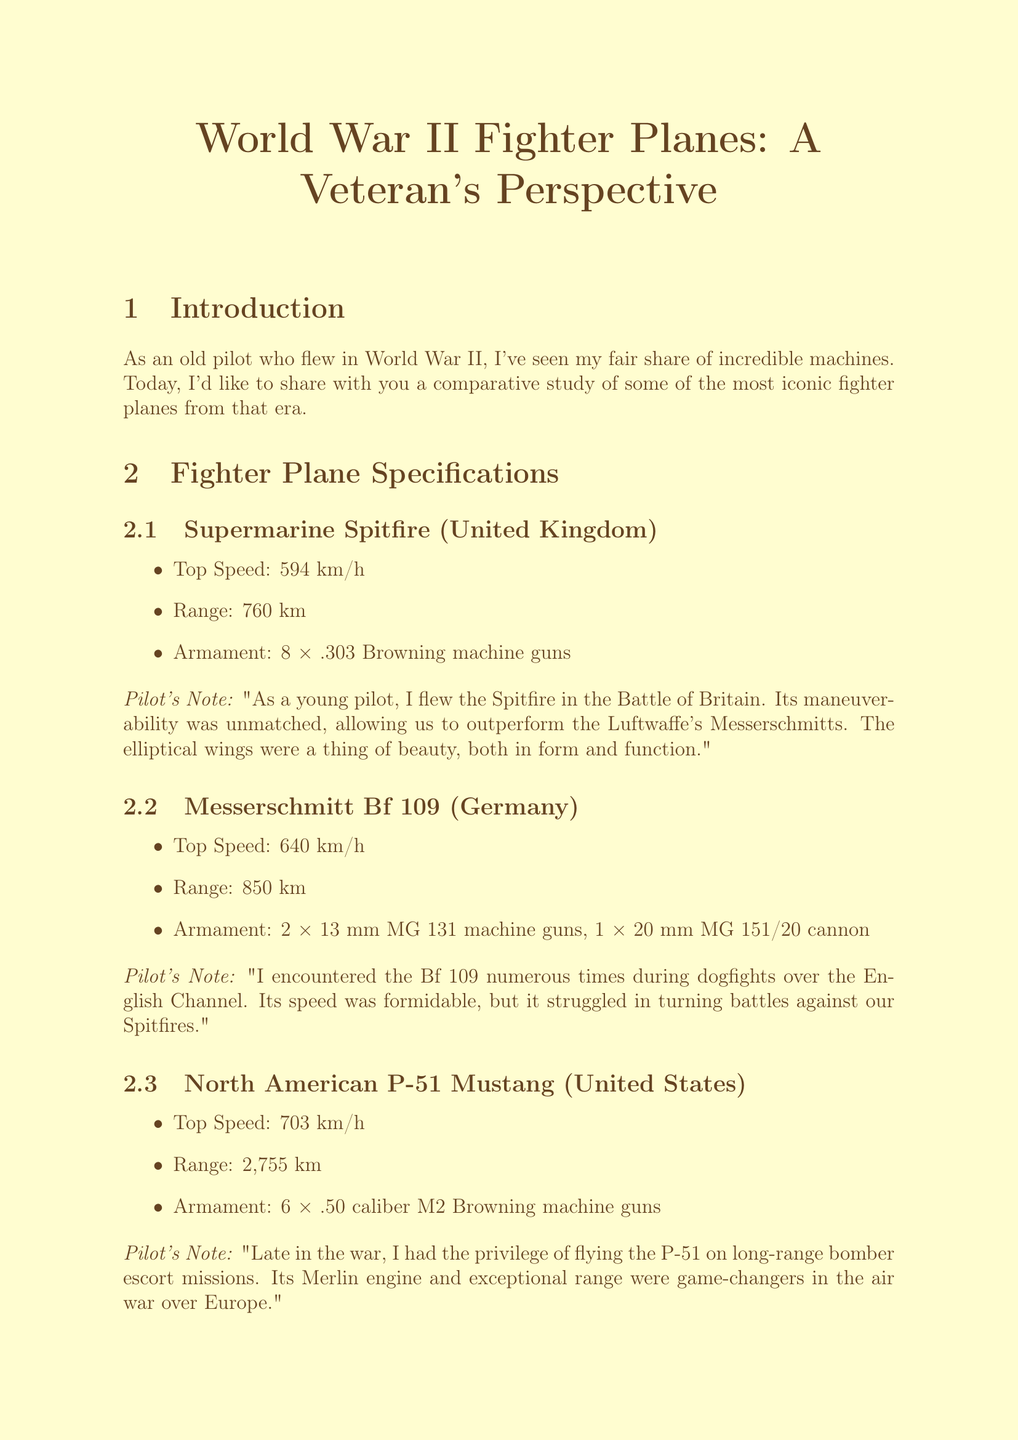what is the top speed of the P-51 Mustang? The top speed of the P-51 Mustang is listed as 703 km/h in the specifications.
Answer: 703 km/h which fighter plane has the longest range? According to the document, the Mitsubishi A6M Zero has the longest range at 3,105 km.
Answer: 3,105 km how many machine guns does the Spitfire have? The specifications for the Spitfire indicate it is armed with 8 × .303 Browning machine guns.
Answer: 8 which two planes are noted for their speed? The document mentions the Messerschmitt Bf 109 and P-51 Mustang specifically for their speed during the comparative analysis.
Answer: Bf 109 and P-51 Mustang what was the primary role of the P-51 Mustang? The P-51 Mustang is described as excelling as a long-range escort fighter in the tactical role section.
Answer: Long-range escort fighter what technological advancement is associated with high-altitude flying? The development of pressurized cockpits is highlighted as a technological advancement for high-altitude flying.
Answer: Pressurized cockpits what sound evokes strong memories for the veteran pilot? The sound of a Merlin engine starting up gives the veteran pilot goosebumps, as mentioned in personal experiences.
Answer: Merlin engine what impact did fighter planes have on ground troop morale? The presence of allied fighters over enemy territory boosted the morale of ground troops, as stated in the impact section.
Answer: Boosted morale 